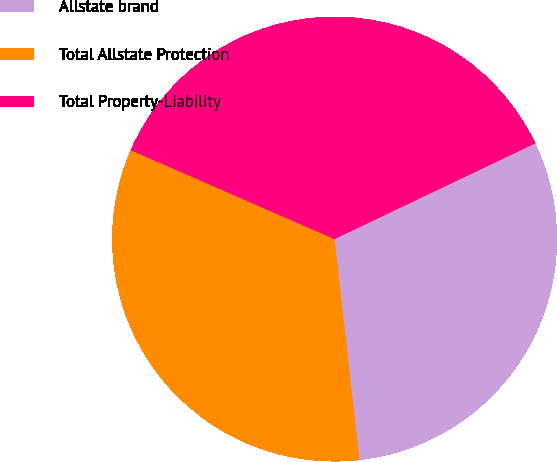Convert chart. <chart><loc_0><loc_0><loc_500><loc_500><pie_chart><fcel>Allstate brand<fcel>Total Allstate Protection<fcel>Total Property-Liability<nl><fcel>30.3%<fcel>33.33%<fcel>36.36%<nl></chart> 